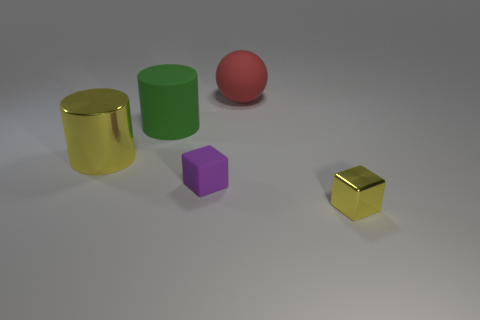Add 3 blue matte cylinders. How many objects exist? 8 Subtract all yellow cylinders. How many cylinders are left? 1 Subtract all cubes. How many objects are left? 3 Subtract 1 yellow cylinders. How many objects are left? 4 Subtract all blue blocks. Subtract all purple balls. How many blocks are left? 2 Subtract all green objects. Subtract all small yellow blocks. How many objects are left? 3 Add 1 large metal cylinders. How many large metal cylinders are left? 2 Add 2 red cubes. How many red cubes exist? 2 